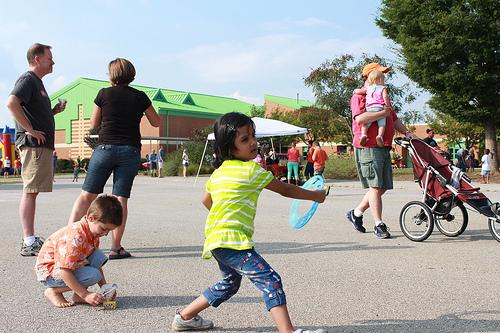Count the number of people who are talking or interacting with each other. There are at least two people, a man and a woman, talking or interacting with each other. Comment on the appearance of the shorts worn by the man with the light brown ones. The man is wearing super tight denim shorts. Mention the color of the shirt worn by the person in the background and what color pants are they wearing. The person in the background is wearing a red shirt and green pants. State the type of stroller and any notable features about it. The stroller is red with large wheels and has a man pushing it. Identify the color and type of outfit the baby girl is wearing. The baby girl is wearing a pink and blue outfit. Explain what the little girl with a white and green shirt is doing. The little girl is holding a blue frisbee, about to throw it. Mention the color of the frisbee and if someone is holding it. There is a light blue frisbee being held in someone's hand. How many wheels does the red and black stroller have? The red and black stroller has 3 wheels. What color and style is the woman's shirt and pants? The woman is wearing a black shirt and blue jeans. Describe the interaction between the man and the baby girl. The man is carrying a baby girl while pushing a red stroller. What is the color of the little boy's shirt? Small orange button up shirt. How many wheels does the red stroller have? 3 wheels. Does the stroller have 4 wheels and is it colored yellow and black? The stroller is described as having 3 wheels and being red and black, not 4 wheels and yellow and black. Identify the objects in motion in the image. Girl preparing to throw a blue frisbee, and little boy playing on the ground. Does the woman holding a black purse and wearing purple jeans? The woman in the image is described as wearing a black shirt and blue jeans, not holding a purse or wearing purple jeans. Identify the sentiment of the image based on the objects and interactions. The sentiment of the image is positive and joyful due to people having fun and interacting with each other. Locate the shadows of people on the pavement. X:121 Y:219 Width:367 Height:367. Identify the objects and their positions in the image. Man with stroller: X:329 Y:55 Width:170 Height:170; Girl with frisbee: X:185 Y:120 Width:155 Height:155; Green-roofed building: X:146 Y:79 Width:107 Height:107. Identify the color and position of the man wearing an orange cap. Color: Orange. Position: X:356 Y:53 Width:36 Height:36. How does the blue frisbee appear to be moving? About to be thrown. Describe the appearance of the woman wearing a black shirt and blue jeans. Position: X:68 Y:48 Width:89 Height:89; She is facing away from the camera, wearing blue jeans and a black shirt. Is the man holding an orange umbrella in his hand? The man is described as holding a cup in his hand, not an orange umbrella. Is there a young boy with a bag of candy in the image? Yes, there is a young boy with a bag of candy in the image. What is the color and position of the building with a green roof? Color: Lime green. Position: X:146 Y:79 Width:107 Height:107. Can you see a tall building with a purple roof? The building in the image has a lime green roof, not a purple roof. Is the baby girl wearing a purple and yellow outfit? The baby girl is described as wearing a pink and blue outfit, not purple and yellow. Find the text present on the black Nike shoes. "Nike" What color is the stroller in the image? Red and black. Segment the person wearing a red shirt and green pants. Position: X:277 Y:138 Width:28 Height:28. Identify the position of a man standing and holding a drink. X:7 Y:44 Width:63 Height:63. Evaluate the quality of the image in terms of resolution and visibility of objects. The image has a satisfactory resolution and all objects are visible clearly. Is the little boy wearing white socks and blue sandals? The little boy is described as not having shoes on, so he wouldn't be wearing socks and sandals. Analyze the interaction between the baby girl and the man holding her. The man is carrying the baby girl in a protective and caring manner. Describe the scene in the image. The image contains a man pushing a red stroller, a man holding a baby, a girl with blue frisbee, people in the background, and a building with a green roof. Describe the appearance of the man pushing an empty baby stroller. Position: X:343 Y:61 Width:82 Height:82; He is wearing light brown shorts and is focused on pushing the stroller. 